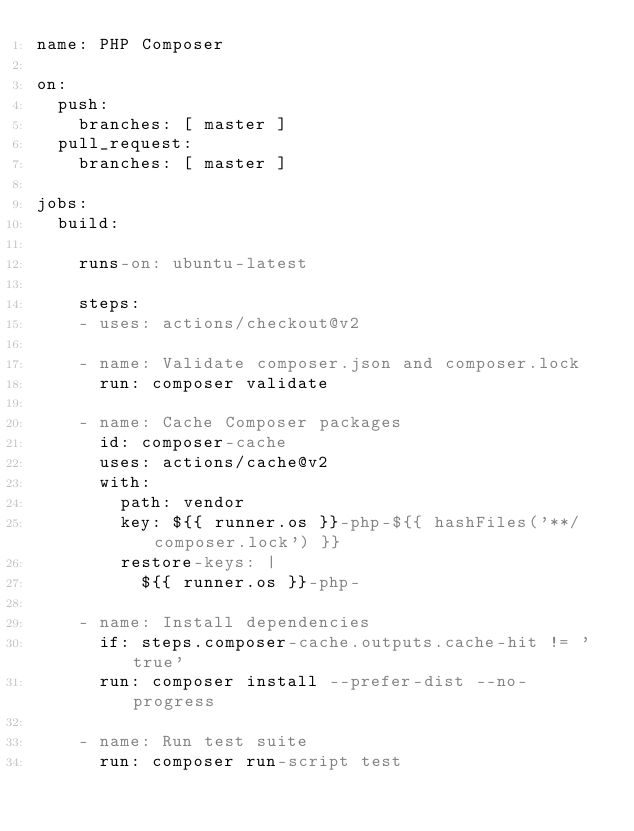Convert code to text. <code><loc_0><loc_0><loc_500><loc_500><_YAML_>name: PHP Composer

on:
  push:
    branches: [ master ]
  pull_request:
    branches: [ master ]

jobs:
  build:

    runs-on: ubuntu-latest

    steps:
    - uses: actions/checkout@v2

    - name: Validate composer.json and composer.lock
      run: composer validate

    - name: Cache Composer packages
      id: composer-cache
      uses: actions/cache@v2
      with:
        path: vendor
        key: ${{ runner.os }}-php-${{ hashFiles('**/composer.lock') }}
        restore-keys: |
          ${{ runner.os }}-php-

    - name: Install dependencies
      if: steps.composer-cache.outputs.cache-hit != 'true'
      run: composer install --prefer-dist --no-progress

    - name: Run test suite
      run: composer run-script test
</code> 